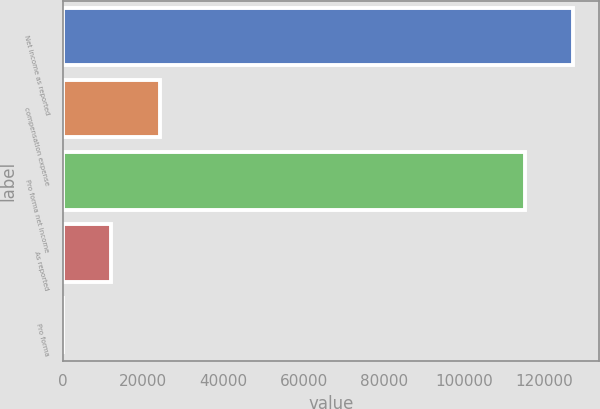Convert chart. <chart><loc_0><loc_0><loc_500><loc_500><bar_chart><fcel>Net income as reported<fcel>compensation expense<fcel>Pro forma net income<fcel>As reported<fcel>Pro forma<nl><fcel>127206<fcel>24129.9<fcel>115142<fcel>12065.8<fcel>1.61<nl></chart> 